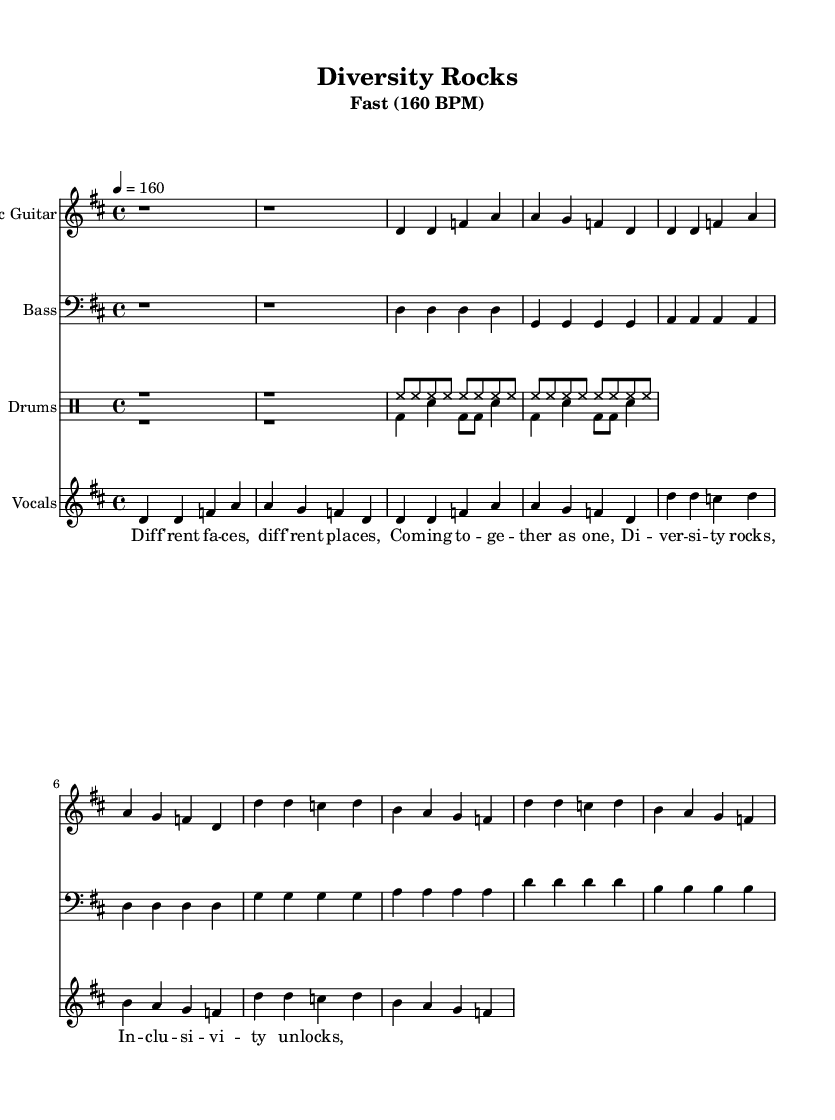What is the key signature of this music? The key signature is D major, which has two sharps (F# and C#). This can be identified at the beginning of the sheet music, where the key signature is indicated.
Answer: D major What is the time signature of this music? The time signature is 4/4, which means there are four beats per measure. This is found right after the key signature at the beginning of the sheet music.
Answer: 4/4 What is the tempo marking for this piece? The tempo marking is 160 BPM (beats per minute). It is written at the beginning under the title and indicates how fast the piece should be played.
Answer: 160 BPM How many measures are in the introductory section? There are two measures in the introduction, as indicated by the repeated "r1" for both measures. Each "r1" represents a whole rest, which means no notes are played.
Answer: 2 What unique characteristic do punk tracks typically have, as shown in this piece? Punk tracks often have a fast-paced tempo and strong rhythms, which is evident here as the tempo is set at 160 BPM, and the rhythm is straightforward and energetic. This reflects the punk style's emphasis on speed and intensity.
Answer: Fast-paced tempo What is the lyrical theme of the chorus? The lyrical theme of the chorus centers around diversity and inclusivity, as indicated by the lines "Diversity rocks, Inclusivity unlocks." This reflects a message of togetherness and acceptance, typical of punk's social commentary.
Answer: Diversity and inclusivity 